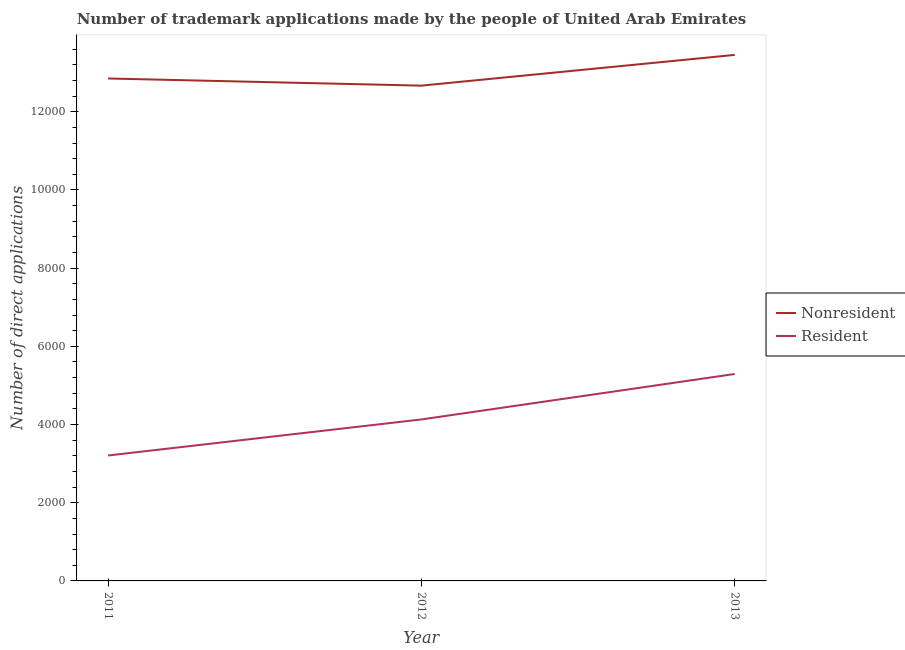How many different coloured lines are there?
Make the answer very short. 2. Does the line corresponding to number of trademark applications made by non residents intersect with the line corresponding to number of trademark applications made by residents?
Offer a very short reply. No. Is the number of lines equal to the number of legend labels?
Offer a very short reply. Yes. What is the number of trademark applications made by non residents in 2012?
Provide a succinct answer. 1.27e+04. Across all years, what is the maximum number of trademark applications made by non residents?
Give a very brief answer. 1.35e+04. Across all years, what is the minimum number of trademark applications made by non residents?
Your answer should be very brief. 1.27e+04. What is the total number of trademark applications made by non residents in the graph?
Offer a terse response. 3.90e+04. What is the difference between the number of trademark applications made by residents in 2011 and that in 2013?
Give a very brief answer. -2085. What is the difference between the number of trademark applications made by residents in 2013 and the number of trademark applications made by non residents in 2011?
Your answer should be very brief. -7558. What is the average number of trademark applications made by residents per year?
Your answer should be compact. 4210.33. In the year 2012, what is the difference between the number of trademark applications made by residents and number of trademark applications made by non residents?
Keep it short and to the point. -8538. What is the ratio of the number of trademark applications made by residents in 2011 to that in 2013?
Ensure brevity in your answer.  0.61. Is the number of trademark applications made by non residents in 2011 less than that in 2013?
Provide a succinct answer. Yes. Is the difference between the number of trademark applications made by residents in 2011 and 2012 greater than the difference between the number of trademark applications made by non residents in 2011 and 2012?
Your answer should be compact. No. What is the difference between the highest and the second highest number of trademark applications made by non residents?
Give a very brief answer. 603. What is the difference between the highest and the lowest number of trademark applications made by non residents?
Offer a very short reply. 786. In how many years, is the number of trademark applications made by non residents greater than the average number of trademark applications made by non residents taken over all years?
Give a very brief answer. 1. Is the sum of the number of trademark applications made by non residents in 2012 and 2013 greater than the maximum number of trademark applications made by residents across all years?
Provide a succinct answer. Yes. Does the number of trademark applications made by non residents monotonically increase over the years?
Provide a short and direct response. No. Is the number of trademark applications made by residents strictly greater than the number of trademark applications made by non residents over the years?
Keep it short and to the point. No. Is the number of trademark applications made by non residents strictly less than the number of trademark applications made by residents over the years?
Keep it short and to the point. No. How many lines are there?
Offer a very short reply. 2. What is the difference between two consecutive major ticks on the Y-axis?
Keep it short and to the point. 2000. Are the values on the major ticks of Y-axis written in scientific E-notation?
Your answer should be compact. No. Does the graph contain any zero values?
Your answer should be very brief. No. Does the graph contain grids?
Your answer should be very brief. No. Where does the legend appear in the graph?
Offer a terse response. Center right. How many legend labels are there?
Offer a terse response. 2. What is the title of the graph?
Offer a very short reply. Number of trademark applications made by the people of United Arab Emirates. What is the label or title of the Y-axis?
Ensure brevity in your answer.  Number of direct applications. What is the Number of direct applications in Nonresident in 2011?
Ensure brevity in your answer.  1.29e+04. What is the Number of direct applications of Resident in 2011?
Make the answer very short. 3208. What is the Number of direct applications in Nonresident in 2012?
Keep it short and to the point. 1.27e+04. What is the Number of direct applications of Resident in 2012?
Your response must be concise. 4130. What is the Number of direct applications of Nonresident in 2013?
Keep it short and to the point. 1.35e+04. What is the Number of direct applications of Resident in 2013?
Your answer should be compact. 5293. Across all years, what is the maximum Number of direct applications of Nonresident?
Your answer should be compact. 1.35e+04. Across all years, what is the maximum Number of direct applications in Resident?
Provide a short and direct response. 5293. Across all years, what is the minimum Number of direct applications in Nonresident?
Provide a short and direct response. 1.27e+04. Across all years, what is the minimum Number of direct applications in Resident?
Provide a succinct answer. 3208. What is the total Number of direct applications in Nonresident in the graph?
Keep it short and to the point. 3.90e+04. What is the total Number of direct applications of Resident in the graph?
Offer a very short reply. 1.26e+04. What is the difference between the Number of direct applications in Nonresident in 2011 and that in 2012?
Offer a terse response. 183. What is the difference between the Number of direct applications in Resident in 2011 and that in 2012?
Ensure brevity in your answer.  -922. What is the difference between the Number of direct applications of Nonresident in 2011 and that in 2013?
Keep it short and to the point. -603. What is the difference between the Number of direct applications of Resident in 2011 and that in 2013?
Make the answer very short. -2085. What is the difference between the Number of direct applications in Nonresident in 2012 and that in 2013?
Offer a terse response. -786. What is the difference between the Number of direct applications in Resident in 2012 and that in 2013?
Make the answer very short. -1163. What is the difference between the Number of direct applications in Nonresident in 2011 and the Number of direct applications in Resident in 2012?
Your response must be concise. 8721. What is the difference between the Number of direct applications in Nonresident in 2011 and the Number of direct applications in Resident in 2013?
Ensure brevity in your answer.  7558. What is the difference between the Number of direct applications of Nonresident in 2012 and the Number of direct applications of Resident in 2013?
Offer a terse response. 7375. What is the average Number of direct applications of Nonresident per year?
Offer a terse response. 1.30e+04. What is the average Number of direct applications in Resident per year?
Keep it short and to the point. 4210.33. In the year 2011, what is the difference between the Number of direct applications of Nonresident and Number of direct applications of Resident?
Provide a succinct answer. 9643. In the year 2012, what is the difference between the Number of direct applications in Nonresident and Number of direct applications in Resident?
Provide a succinct answer. 8538. In the year 2013, what is the difference between the Number of direct applications of Nonresident and Number of direct applications of Resident?
Keep it short and to the point. 8161. What is the ratio of the Number of direct applications of Nonresident in 2011 to that in 2012?
Keep it short and to the point. 1.01. What is the ratio of the Number of direct applications in Resident in 2011 to that in 2012?
Give a very brief answer. 0.78. What is the ratio of the Number of direct applications in Nonresident in 2011 to that in 2013?
Offer a terse response. 0.96. What is the ratio of the Number of direct applications in Resident in 2011 to that in 2013?
Give a very brief answer. 0.61. What is the ratio of the Number of direct applications of Nonresident in 2012 to that in 2013?
Your answer should be very brief. 0.94. What is the ratio of the Number of direct applications of Resident in 2012 to that in 2013?
Make the answer very short. 0.78. What is the difference between the highest and the second highest Number of direct applications of Nonresident?
Offer a terse response. 603. What is the difference between the highest and the second highest Number of direct applications in Resident?
Provide a succinct answer. 1163. What is the difference between the highest and the lowest Number of direct applications of Nonresident?
Provide a succinct answer. 786. What is the difference between the highest and the lowest Number of direct applications of Resident?
Your answer should be very brief. 2085. 